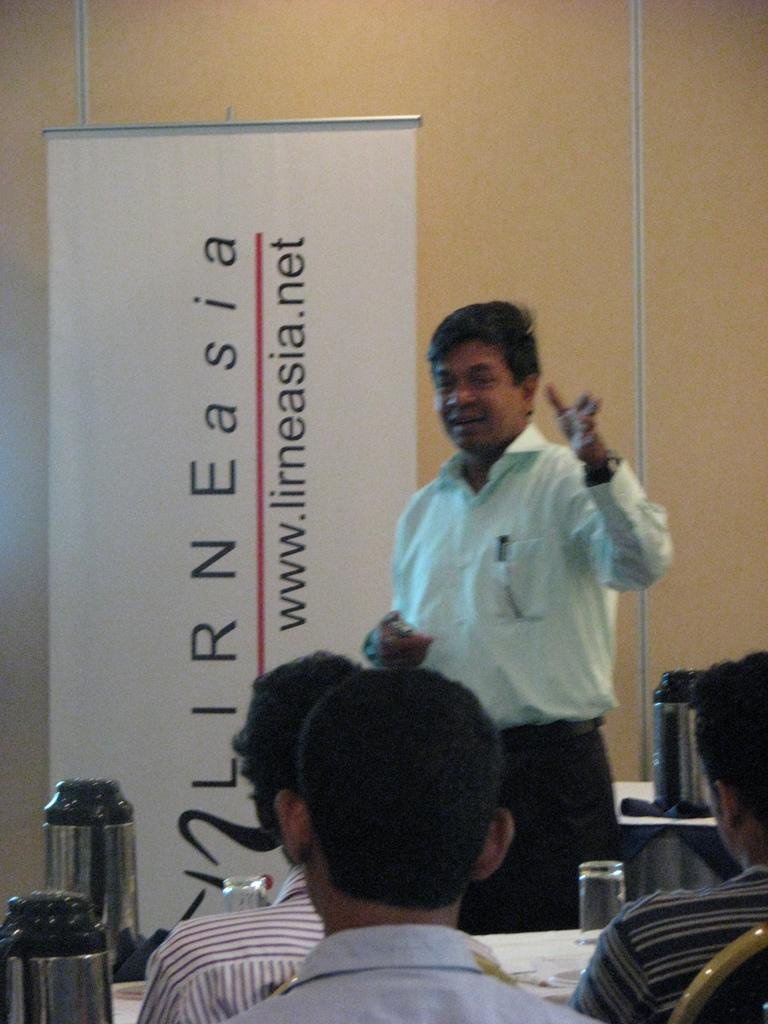<image>
Create a compact narrative representing the image presented. A man speaks to a group near a sign that says www.lirneasia.net. 